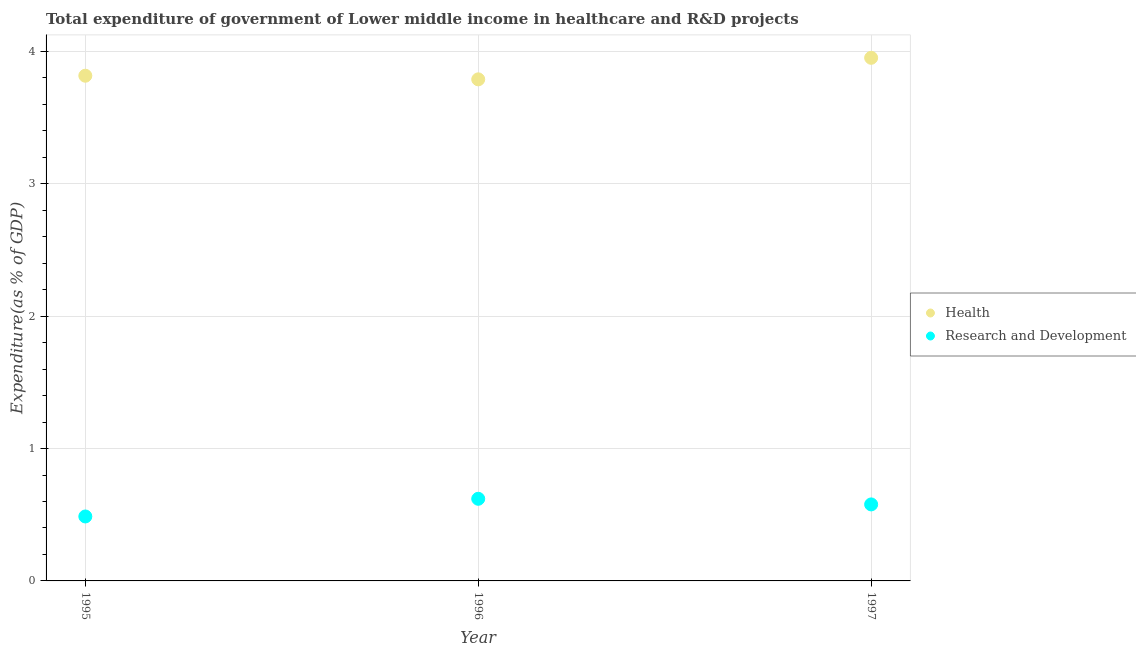How many different coloured dotlines are there?
Give a very brief answer. 2. What is the expenditure in r&d in 1995?
Offer a very short reply. 0.49. Across all years, what is the maximum expenditure in healthcare?
Offer a very short reply. 3.95. Across all years, what is the minimum expenditure in r&d?
Offer a terse response. 0.49. In which year was the expenditure in r&d maximum?
Ensure brevity in your answer.  1996. In which year was the expenditure in r&d minimum?
Provide a succinct answer. 1995. What is the total expenditure in r&d in the graph?
Give a very brief answer. 1.69. What is the difference between the expenditure in r&d in 1995 and that in 1996?
Your answer should be very brief. -0.13. What is the difference between the expenditure in r&d in 1997 and the expenditure in healthcare in 1996?
Give a very brief answer. -3.21. What is the average expenditure in healthcare per year?
Provide a succinct answer. 3.85. In the year 1997, what is the difference between the expenditure in healthcare and expenditure in r&d?
Keep it short and to the point. 3.37. What is the ratio of the expenditure in r&d in 1996 to that in 1997?
Your answer should be compact. 1.07. Is the expenditure in r&d in 1995 less than that in 1997?
Provide a short and direct response. Yes. What is the difference between the highest and the second highest expenditure in healthcare?
Provide a short and direct response. 0.14. What is the difference between the highest and the lowest expenditure in healthcare?
Your response must be concise. 0.16. Does the expenditure in r&d monotonically increase over the years?
Ensure brevity in your answer.  No. Is the expenditure in r&d strictly less than the expenditure in healthcare over the years?
Offer a very short reply. Yes. How many dotlines are there?
Keep it short and to the point. 2. Are the values on the major ticks of Y-axis written in scientific E-notation?
Provide a short and direct response. No. Where does the legend appear in the graph?
Your answer should be compact. Center right. How many legend labels are there?
Your response must be concise. 2. What is the title of the graph?
Provide a succinct answer. Total expenditure of government of Lower middle income in healthcare and R&D projects. What is the label or title of the X-axis?
Provide a succinct answer. Year. What is the label or title of the Y-axis?
Offer a terse response. Expenditure(as % of GDP). What is the Expenditure(as % of GDP) of Health in 1995?
Ensure brevity in your answer.  3.82. What is the Expenditure(as % of GDP) of Research and Development in 1995?
Your answer should be compact. 0.49. What is the Expenditure(as % of GDP) of Health in 1996?
Offer a very short reply. 3.79. What is the Expenditure(as % of GDP) of Research and Development in 1996?
Give a very brief answer. 0.62. What is the Expenditure(as % of GDP) in Health in 1997?
Offer a terse response. 3.95. What is the Expenditure(as % of GDP) in Research and Development in 1997?
Keep it short and to the point. 0.58. Across all years, what is the maximum Expenditure(as % of GDP) in Health?
Keep it short and to the point. 3.95. Across all years, what is the maximum Expenditure(as % of GDP) in Research and Development?
Offer a very short reply. 0.62. Across all years, what is the minimum Expenditure(as % of GDP) of Health?
Offer a terse response. 3.79. Across all years, what is the minimum Expenditure(as % of GDP) in Research and Development?
Your answer should be very brief. 0.49. What is the total Expenditure(as % of GDP) in Health in the graph?
Your response must be concise. 11.56. What is the total Expenditure(as % of GDP) in Research and Development in the graph?
Offer a terse response. 1.69. What is the difference between the Expenditure(as % of GDP) in Health in 1995 and that in 1996?
Make the answer very short. 0.03. What is the difference between the Expenditure(as % of GDP) of Research and Development in 1995 and that in 1996?
Your answer should be compact. -0.13. What is the difference between the Expenditure(as % of GDP) in Health in 1995 and that in 1997?
Your answer should be compact. -0.14. What is the difference between the Expenditure(as % of GDP) of Research and Development in 1995 and that in 1997?
Keep it short and to the point. -0.09. What is the difference between the Expenditure(as % of GDP) in Health in 1996 and that in 1997?
Provide a short and direct response. -0.16. What is the difference between the Expenditure(as % of GDP) in Research and Development in 1996 and that in 1997?
Make the answer very short. 0.04. What is the difference between the Expenditure(as % of GDP) of Health in 1995 and the Expenditure(as % of GDP) of Research and Development in 1996?
Keep it short and to the point. 3.2. What is the difference between the Expenditure(as % of GDP) in Health in 1995 and the Expenditure(as % of GDP) in Research and Development in 1997?
Your answer should be compact. 3.24. What is the difference between the Expenditure(as % of GDP) of Health in 1996 and the Expenditure(as % of GDP) of Research and Development in 1997?
Your answer should be very brief. 3.21. What is the average Expenditure(as % of GDP) in Health per year?
Give a very brief answer. 3.85. What is the average Expenditure(as % of GDP) in Research and Development per year?
Offer a very short reply. 0.56. In the year 1995, what is the difference between the Expenditure(as % of GDP) of Health and Expenditure(as % of GDP) of Research and Development?
Keep it short and to the point. 3.33. In the year 1996, what is the difference between the Expenditure(as % of GDP) of Health and Expenditure(as % of GDP) of Research and Development?
Your answer should be compact. 3.17. In the year 1997, what is the difference between the Expenditure(as % of GDP) in Health and Expenditure(as % of GDP) in Research and Development?
Offer a terse response. 3.37. What is the ratio of the Expenditure(as % of GDP) in Research and Development in 1995 to that in 1996?
Keep it short and to the point. 0.78. What is the ratio of the Expenditure(as % of GDP) in Health in 1995 to that in 1997?
Ensure brevity in your answer.  0.97. What is the ratio of the Expenditure(as % of GDP) of Research and Development in 1995 to that in 1997?
Ensure brevity in your answer.  0.84. What is the ratio of the Expenditure(as % of GDP) in Health in 1996 to that in 1997?
Offer a very short reply. 0.96. What is the ratio of the Expenditure(as % of GDP) of Research and Development in 1996 to that in 1997?
Provide a short and direct response. 1.07. What is the difference between the highest and the second highest Expenditure(as % of GDP) of Health?
Make the answer very short. 0.14. What is the difference between the highest and the second highest Expenditure(as % of GDP) of Research and Development?
Your answer should be very brief. 0.04. What is the difference between the highest and the lowest Expenditure(as % of GDP) in Health?
Provide a short and direct response. 0.16. What is the difference between the highest and the lowest Expenditure(as % of GDP) in Research and Development?
Offer a terse response. 0.13. 